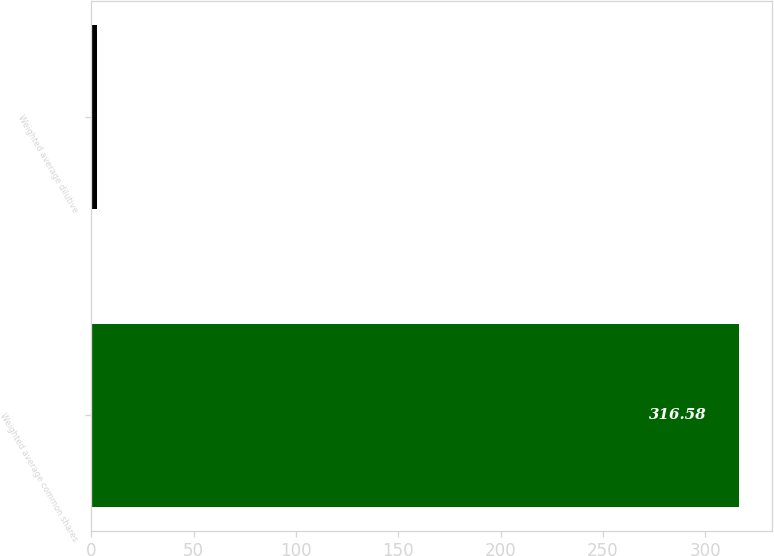Convert chart. <chart><loc_0><loc_0><loc_500><loc_500><bar_chart><fcel>Weighted average common shares<fcel>Weighted average dilutive<nl><fcel>316.58<fcel>2.8<nl></chart> 